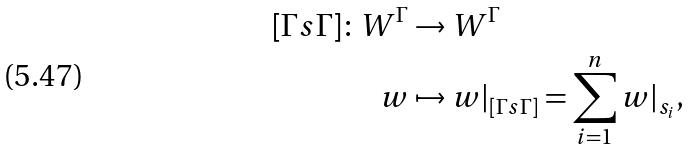Convert formula to latex. <formula><loc_0><loc_0><loc_500><loc_500>[ \Gamma s \Gamma ] \colon W ^ { \Gamma } & \to W ^ { \Gamma } \\ w & \mapsto w | _ { [ \Gamma s \Gamma ] } = \sum _ { i = 1 } ^ { n } w | _ { s _ { i } } ,</formula> 